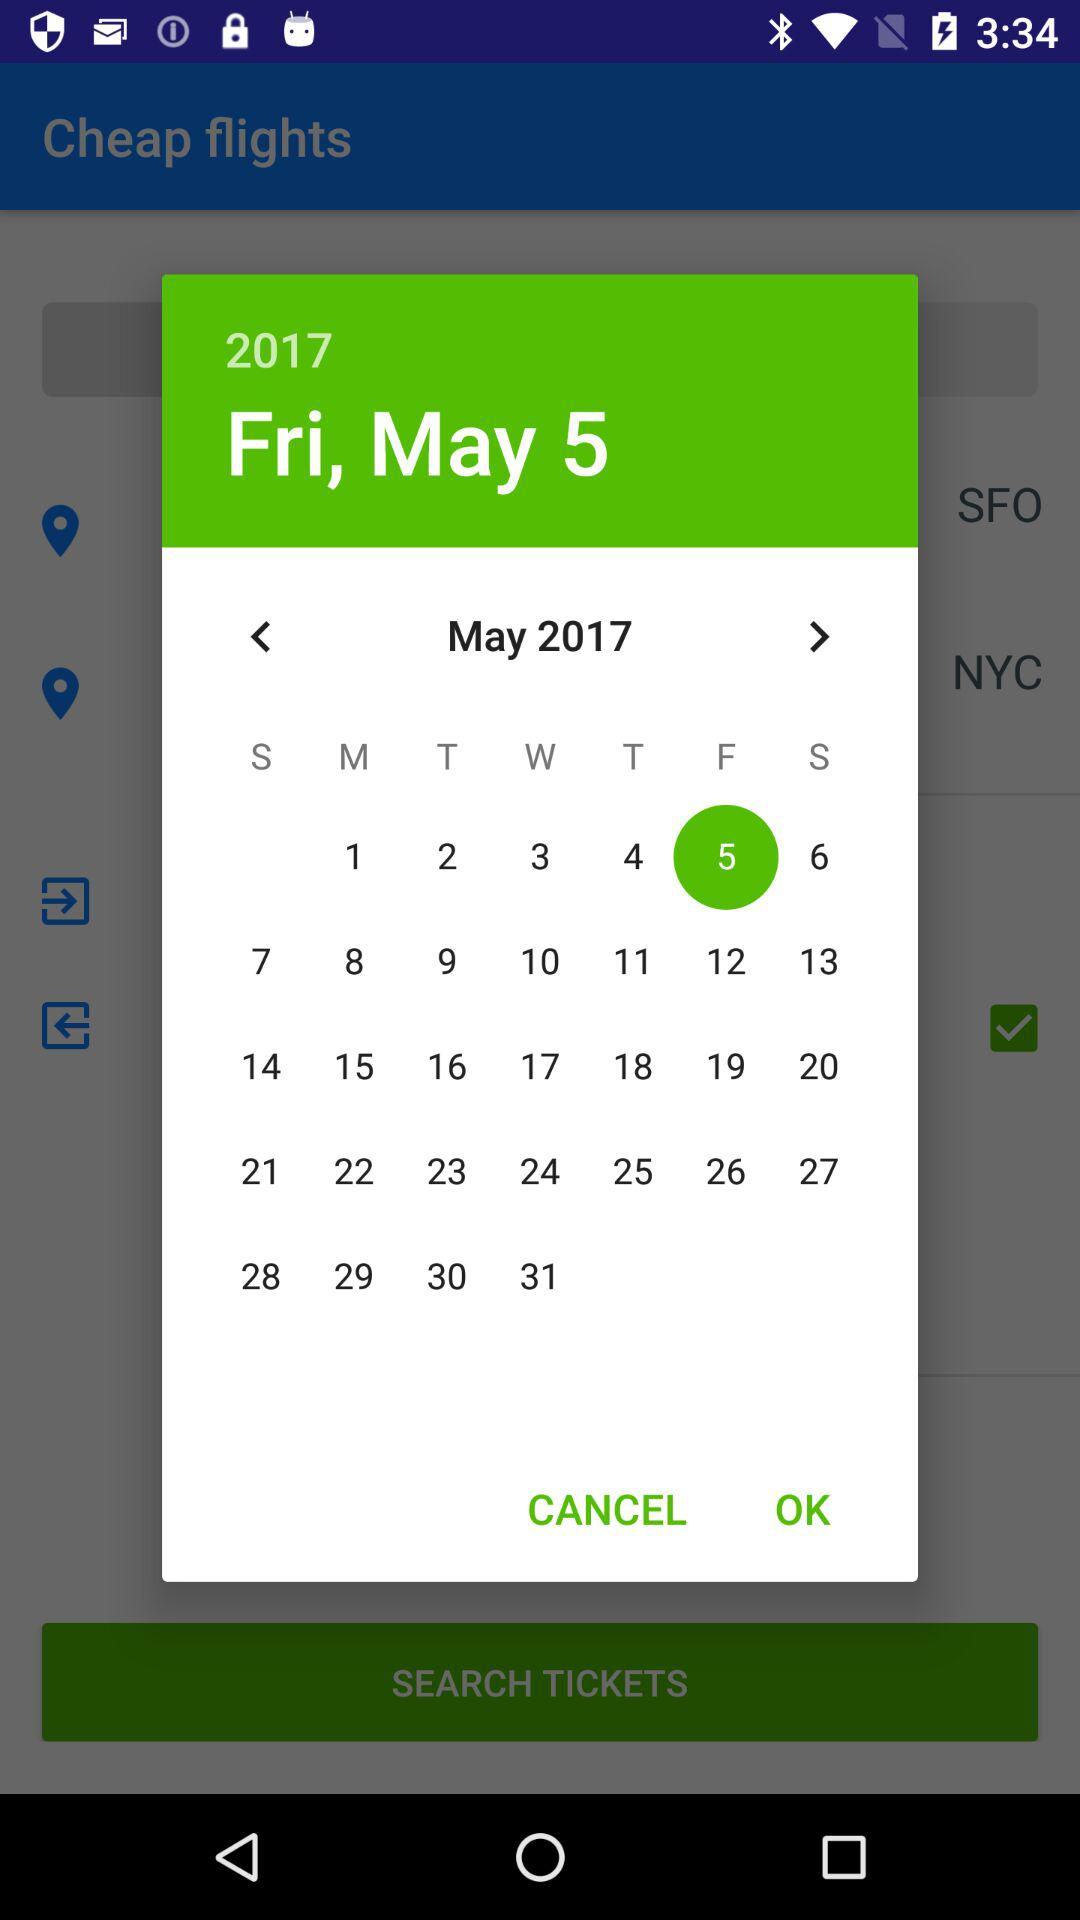Which date is selected on the calendar? The selected date is Friday, May 5, 2017. 